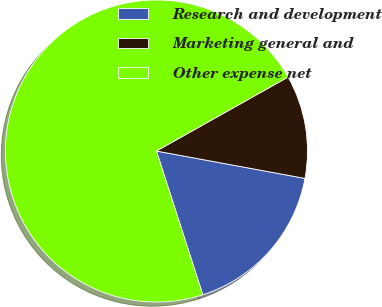Convert chart to OTSL. <chart><loc_0><loc_0><loc_500><loc_500><pie_chart><fcel>Research and development<fcel>Marketing general and<fcel>Other expense net<nl><fcel>17.13%<fcel>11.05%<fcel>71.82%<nl></chart> 